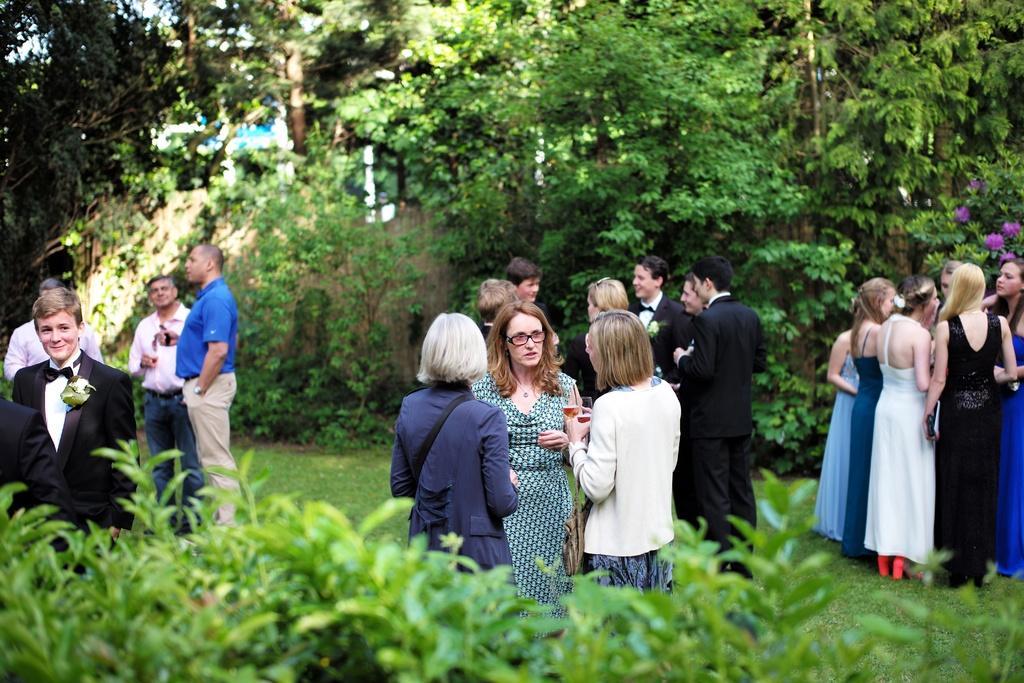Can you describe this image briefly? In this image I can see few trees which are green in color and few persons are standing on the ground and I can see some of them are holding glasses in their hands. I can see few trees, few flowers which are pink in color , few other objects and the sky. 